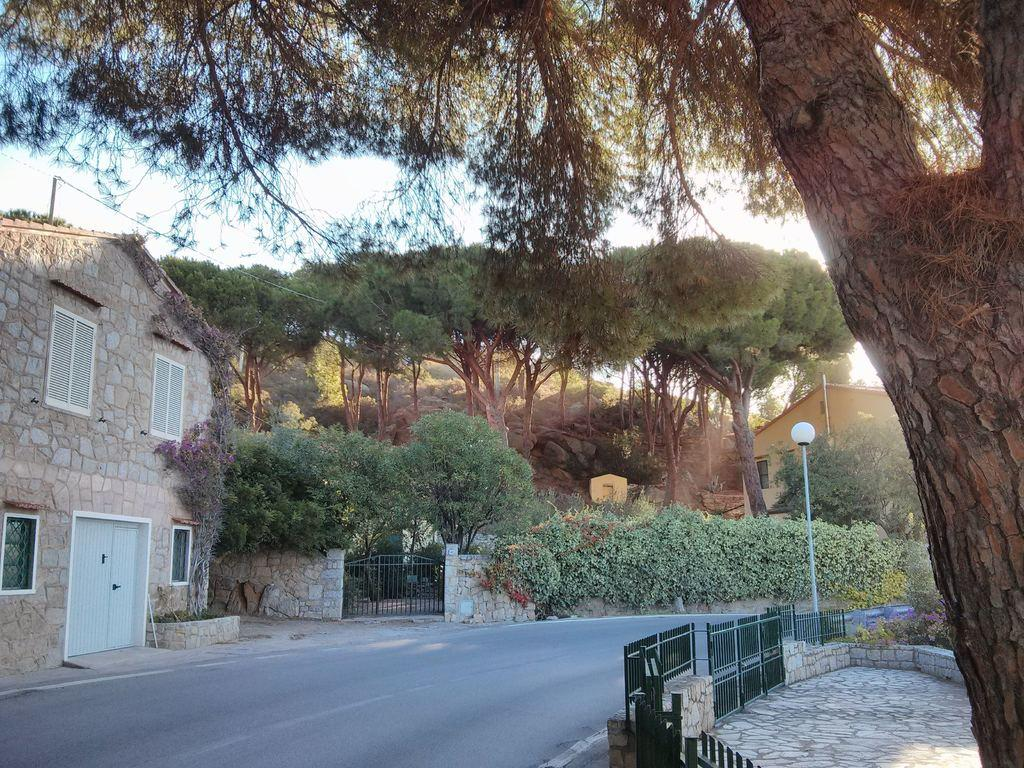What type of structure is present in the image? There is a building in the image. What feature can be seen on the building? The building has windows. What is the color of the gate in the image? The gate in the image is black in color. What type of barrier is present in the image? There is fencing in the image. What is the color of the pole visible in the image? The pole in the image is white in color. What type of vegetation is present in the image? There are trees in the image. What is the color of the sky in the image? The sky appears to be white in color. What is the color of the door in the image? There is a white color door in the image. Where is the drawer located in the image? There is no drawer present in the image. What type of vegetable can be seen growing in the image? There are no vegetables visible in the image; only trees are present. 